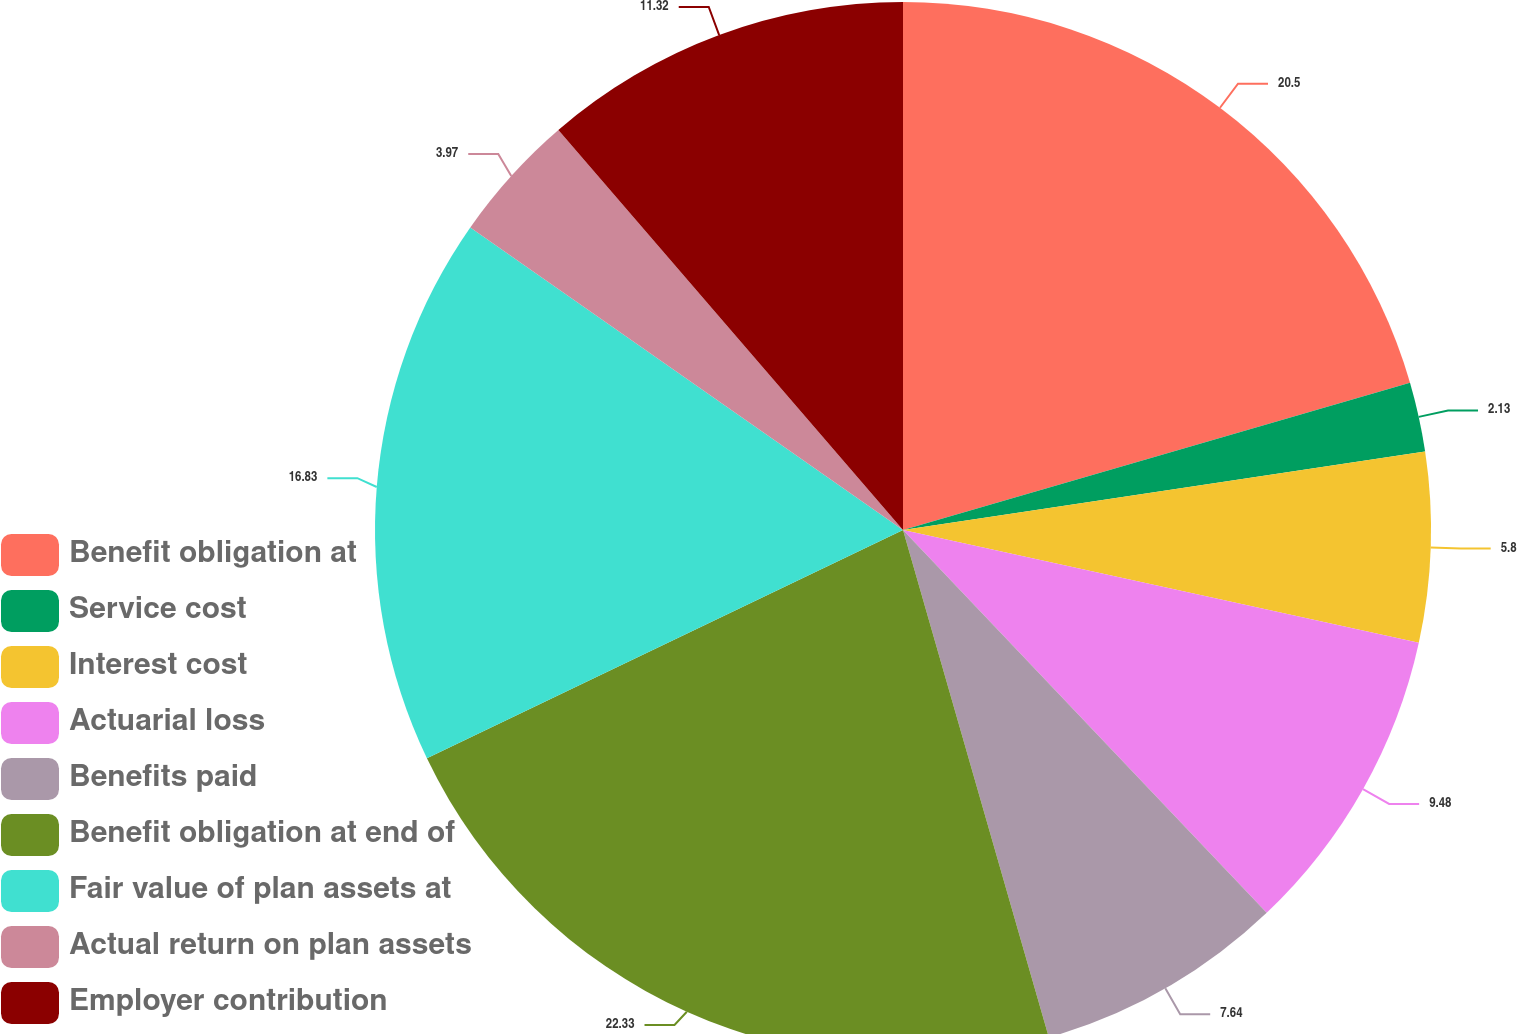Convert chart to OTSL. <chart><loc_0><loc_0><loc_500><loc_500><pie_chart><fcel>Benefit obligation at<fcel>Service cost<fcel>Interest cost<fcel>Actuarial loss<fcel>Benefits paid<fcel>Benefit obligation at end of<fcel>Fair value of plan assets at<fcel>Actual return on plan assets<fcel>Employer contribution<nl><fcel>20.5%<fcel>2.13%<fcel>5.8%<fcel>9.48%<fcel>7.64%<fcel>22.34%<fcel>16.83%<fcel>3.97%<fcel>11.32%<nl></chart> 